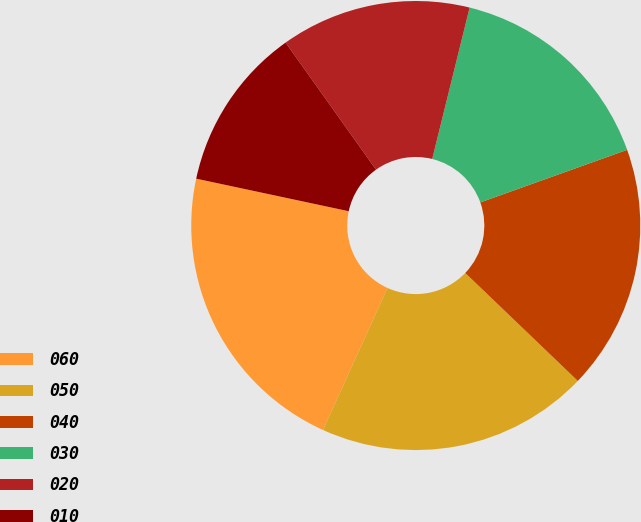<chart> <loc_0><loc_0><loc_500><loc_500><pie_chart><fcel>060<fcel>050<fcel>040<fcel>030<fcel>020<fcel>010<nl><fcel>21.57%<fcel>19.61%<fcel>17.64%<fcel>15.67%<fcel>13.7%<fcel>11.81%<nl></chart> 